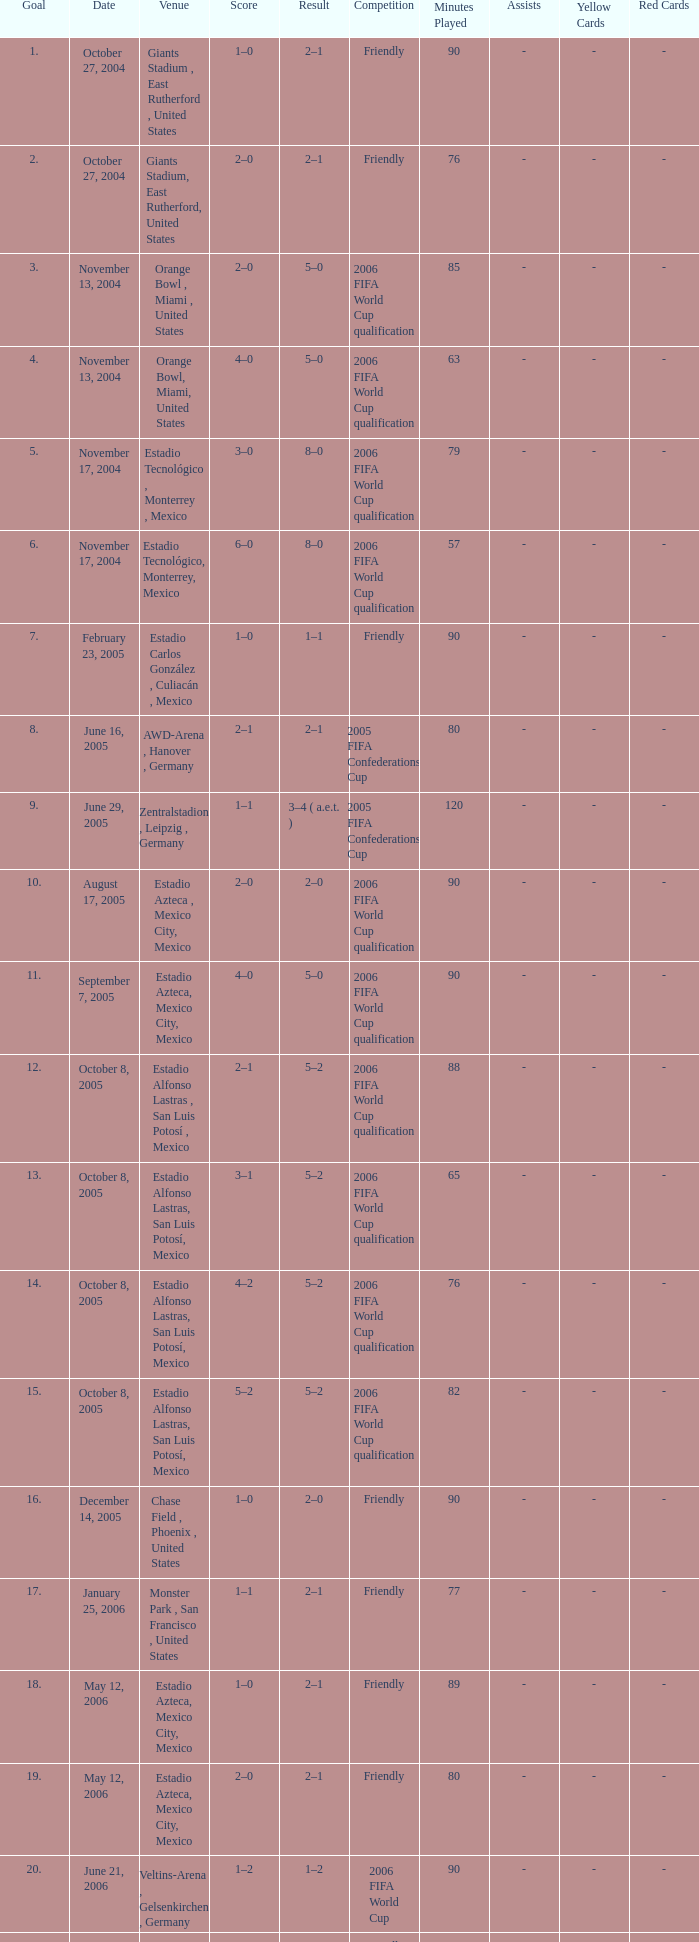Which Score has a Date of october 8, 2005, and a Venue of estadio alfonso lastras, san luis potosí, mexico? 2–1, 3–1, 4–2, 5–2. 